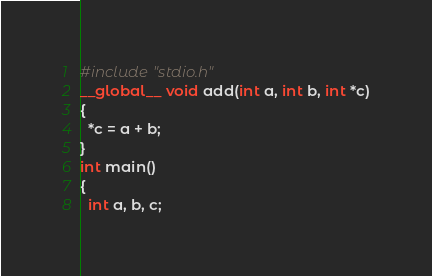Convert code to text. <code><loc_0><loc_0><loc_500><loc_500><_Cuda_>#include "stdio.h"
__global__ void add(int a, int b, int *c)
{
  *c = a + b;
}
int main()
{
  int a, b, c;</code> 